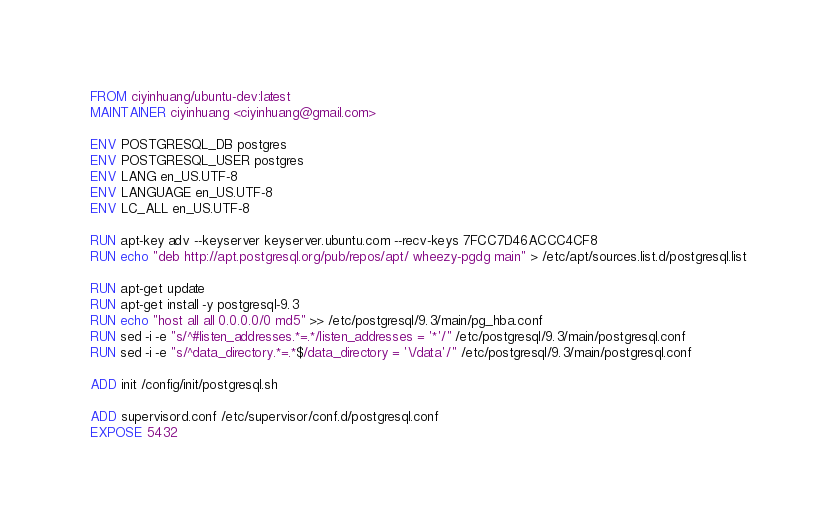<code> <loc_0><loc_0><loc_500><loc_500><_Dockerfile_>FROM ciyinhuang/ubuntu-dev:latest
MAINTAINER ciyinhuang <ciyinhuang@gmail.com>

ENV POSTGRESQL_DB postgres
ENV POSTGRESQL_USER postgres
ENV LANG en_US.UTF-8
ENV LANGUAGE en_US.UTF-8
ENV LC_ALL en_US.UTF-8

RUN apt-key adv --keyserver keyserver.ubuntu.com --recv-keys 7FCC7D46ACCC4CF8
RUN echo "deb http://apt.postgresql.org/pub/repos/apt/ wheezy-pgdg main" > /etc/apt/sources.list.d/postgresql.list

RUN apt-get update
RUN apt-get install -y postgresql-9.3 	
RUN echo "host all all 0.0.0.0/0 md5" >> /etc/postgresql/9.3/main/pg_hba.conf
RUN sed -i -e "s/^#listen_addresses.*=.*/listen_addresses = '*'/" /etc/postgresql/9.3/main/postgresql.conf
RUN sed -i -e "s/^data_directory.*=.*$/data_directory = '\/data'/" /etc/postgresql/9.3/main/postgresql.conf

ADD init /config/init/postgresql.sh

ADD supervisord.conf /etc/supervisor/conf.d/postgresql.conf
EXPOSE 5432
</code> 